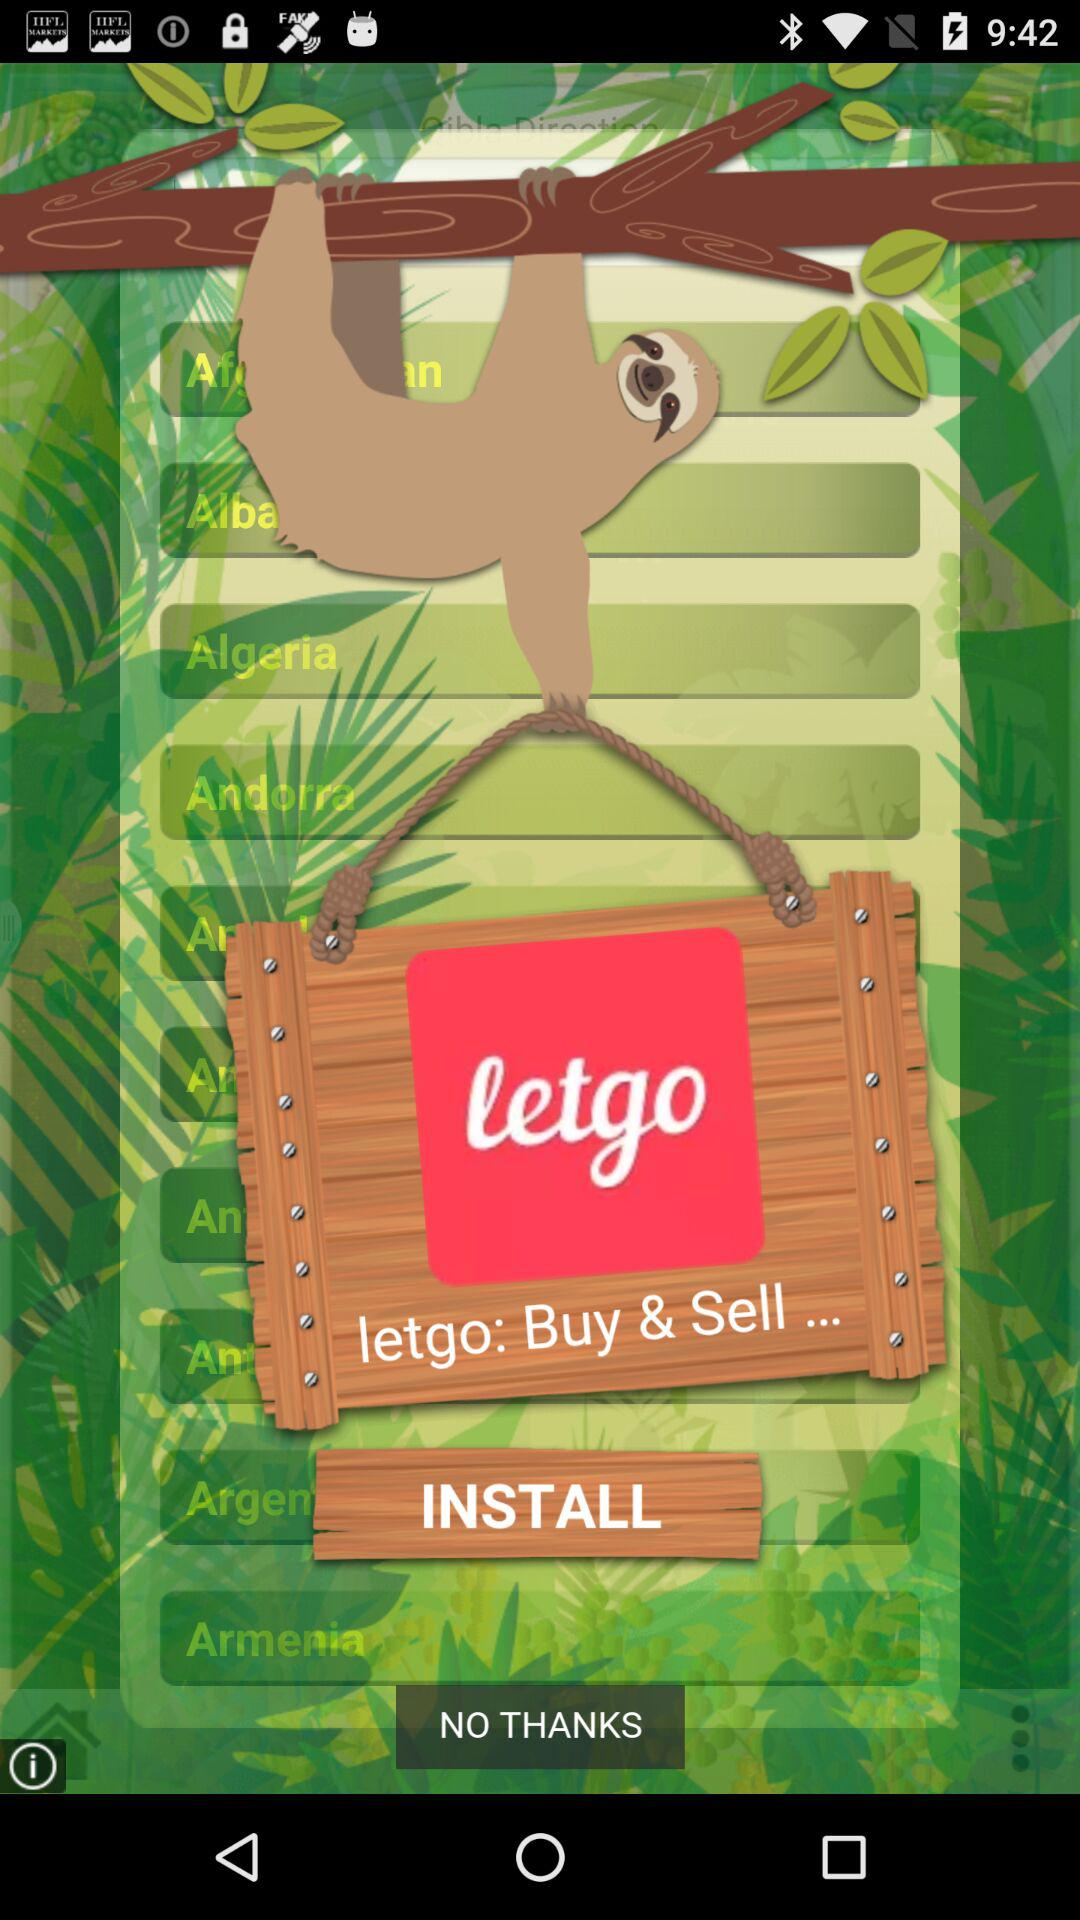Which language is selected?
When the provided information is insufficient, respond with <no answer>. <no answer> 